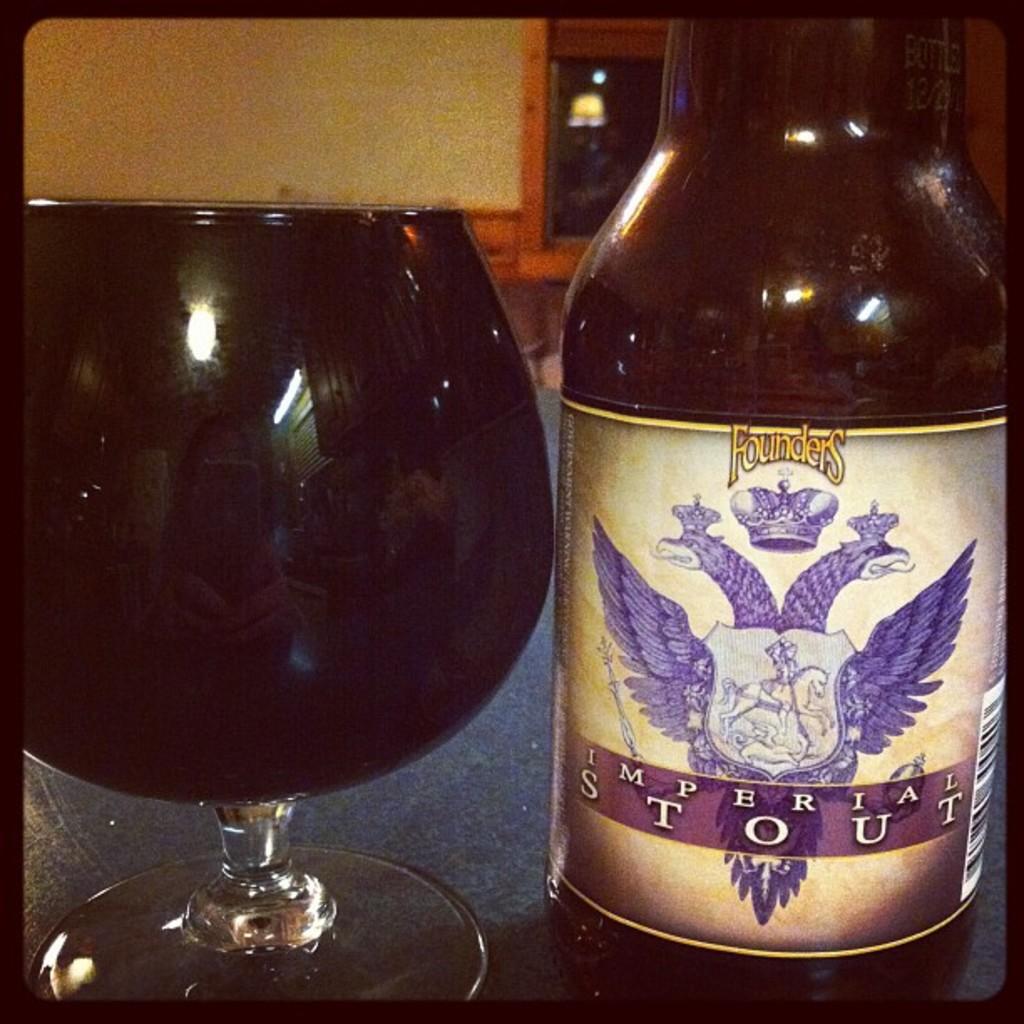What kind of stout is it?
Give a very brief answer. Imperial. What brand is this drink, found at the top?
Give a very brief answer. Founders. 